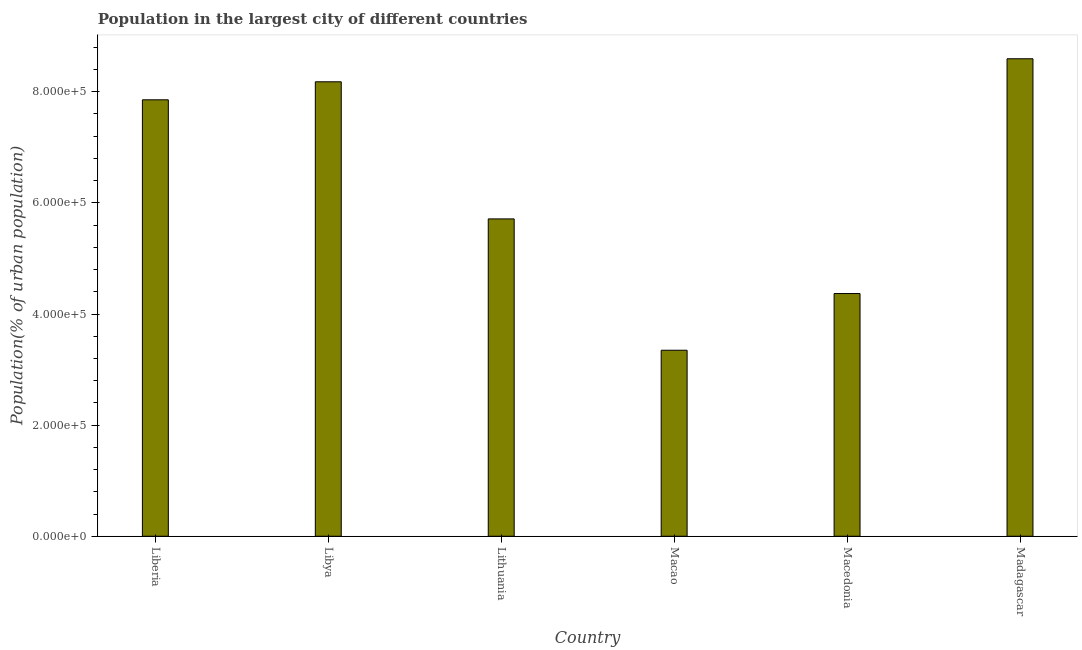Does the graph contain any zero values?
Keep it short and to the point. No. Does the graph contain grids?
Offer a very short reply. No. What is the title of the graph?
Provide a succinct answer. Population in the largest city of different countries. What is the label or title of the X-axis?
Make the answer very short. Country. What is the label or title of the Y-axis?
Offer a terse response. Population(% of urban population). What is the population in largest city in Libya?
Provide a succinct answer. 8.18e+05. Across all countries, what is the maximum population in largest city?
Give a very brief answer. 8.59e+05. Across all countries, what is the minimum population in largest city?
Keep it short and to the point. 3.35e+05. In which country was the population in largest city maximum?
Keep it short and to the point. Madagascar. In which country was the population in largest city minimum?
Keep it short and to the point. Macao. What is the sum of the population in largest city?
Make the answer very short. 3.81e+06. What is the difference between the population in largest city in Liberia and Macedonia?
Provide a short and direct response. 3.49e+05. What is the average population in largest city per country?
Make the answer very short. 6.34e+05. What is the median population in largest city?
Provide a succinct answer. 6.78e+05. In how many countries, is the population in largest city greater than 320000 %?
Give a very brief answer. 6. What is the ratio of the population in largest city in Lithuania to that in Madagascar?
Provide a short and direct response. 0.67. Is the population in largest city in Macao less than that in Madagascar?
Offer a very short reply. Yes. What is the difference between the highest and the second highest population in largest city?
Your answer should be compact. 4.15e+04. Is the sum of the population in largest city in Liberia and Macedonia greater than the maximum population in largest city across all countries?
Make the answer very short. Yes. What is the difference between the highest and the lowest population in largest city?
Provide a succinct answer. 5.25e+05. Are all the bars in the graph horizontal?
Offer a terse response. No. Are the values on the major ticks of Y-axis written in scientific E-notation?
Offer a terse response. Yes. What is the Population(% of urban population) in Liberia?
Offer a very short reply. 7.86e+05. What is the Population(% of urban population) of Libya?
Make the answer very short. 8.18e+05. What is the Population(% of urban population) in Lithuania?
Keep it short and to the point. 5.71e+05. What is the Population(% of urban population) of Macao?
Your answer should be very brief. 3.35e+05. What is the Population(% of urban population) in Macedonia?
Offer a terse response. 4.37e+05. What is the Population(% of urban population) of Madagascar?
Ensure brevity in your answer.  8.59e+05. What is the difference between the Population(% of urban population) in Liberia and Libya?
Your response must be concise. -3.24e+04. What is the difference between the Population(% of urban population) in Liberia and Lithuania?
Make the answer very short. 2.14e+05. What is the difference between the Population(% of urban population) in Liberia and Macao?
Give a very brief answer. 4.51e+05. What is the difference between the Population(% of urban population) in Liberia and Macedonia?
Your answer should be very brief. 3.49e+05. What is the difference between the Population(% of urban population) in Liberia and Madagascar?
Your response must be concise. -7.39e+04. What is the difference between the Population(% of urban population) in Libya and Lithuania?
Ensure brevity in your answer.  2.47e+05. What is the difference between the Population(% of urban population) in Libya and Macao?
Ensure brevity in your answer.  4.83e+05. What is the difference between the Population(% of urban population) in Libya and Macedonia?
Your answer should be compact. 3.81e+05. What is the difference between the Population(% of urban population) in Libya and Madagascar?
Give a very brief answer. -4.15e+04. What is the difference between the Population(% of urban population) in Lithuania and Macao?
Provide a succinct answer. 2.36e+05. What is the difference between the Population(% of urban population) in Lithuania and Macedonia?
Provide a succinct answer. 1.34e+05. What is the difference between the Population(% of urban population) in Lithuania and Madagascar?
Your answer should be compact. -2.88e+05. What is the difference between the Population(% of urban population) in Macao and Macedonia?
Offer a very short reply. -1.02e+05. What is the difference between the Population(% of urban population) in Macao and Madagascar?
Keep it short and to the point. -5.25e+05. What is the difference between the Population(% of urban population) in Macedonia and Madagascar?
Your response must be concise. -4.23e+05. What is the ratio of the Population(% of urban population) in Liberia to that in Libya?
Ensure brevity in your answer.  0.96. What is the ratio of the Population(% of urban population) in Liberia to that in Lithuania?
Ensure brevity in your answer.  1.38. What is the ratio of the Population(% of urban population) in Liberia to that in Macao?
Make the answer very short. 2.35. What is the ratio of the Population(% of urban population) in Liberia to that in Macedonia?
Provide a succinct answer. 1.8. What is the ratio of the Population(% of urban population) in Liberia to that in Madagascar?
Provide a short and direct response. 0.91. What is the ratio of the Population(% of urban population) in Libya to that in Lithuania?
Provide a succinct answer. 1.43. What is the ratio of the Population(% of urban population) in Libya to that in Macao?
Ensure brevity in your answer.  2.44. What is the ratio of the Population(% of urban population) in Libya to that in Macedonia?
Make the answer very short. 1.87. What is the ratio of the Population(% of urban population) in Lithuania to that in Macao?
Give a very brief answer. 1.71. What is the ratio of the Population(% of urban population) in Lithuania to that in Macedonia?
Make the answer very short. 1.31. What is the ratio of the Population(% of urban population) in Lithuania to that in Madagascar?
Make the answer very short. 0.67. What is the ratio of the Population(% of urban population) in Macao to that in Macedonia?
Give a very brief answer. 0.77. What is the ratio of the Population(% of urban population) in Macao to that in Madagascar?
Offer a terse response. 0.39. What is the ratio of the Population(% of urban population) in Macedonia to that in Madagascar?
Your answer should be compact. 0.51. 